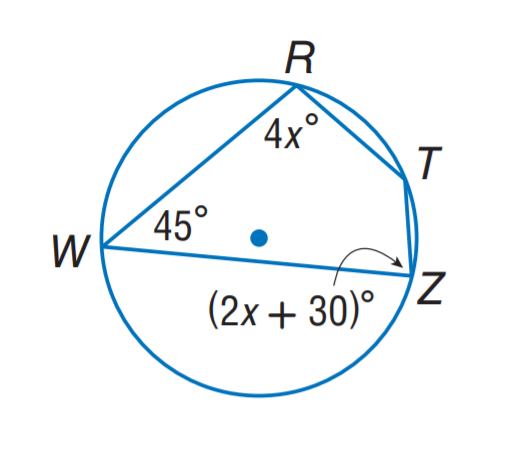Answer the mathemtical geometry problem and directly provide the correct option letter.
Question: Find m \angle T.
Choices: A: 80 B: 120 C: 135 D: 145 C 